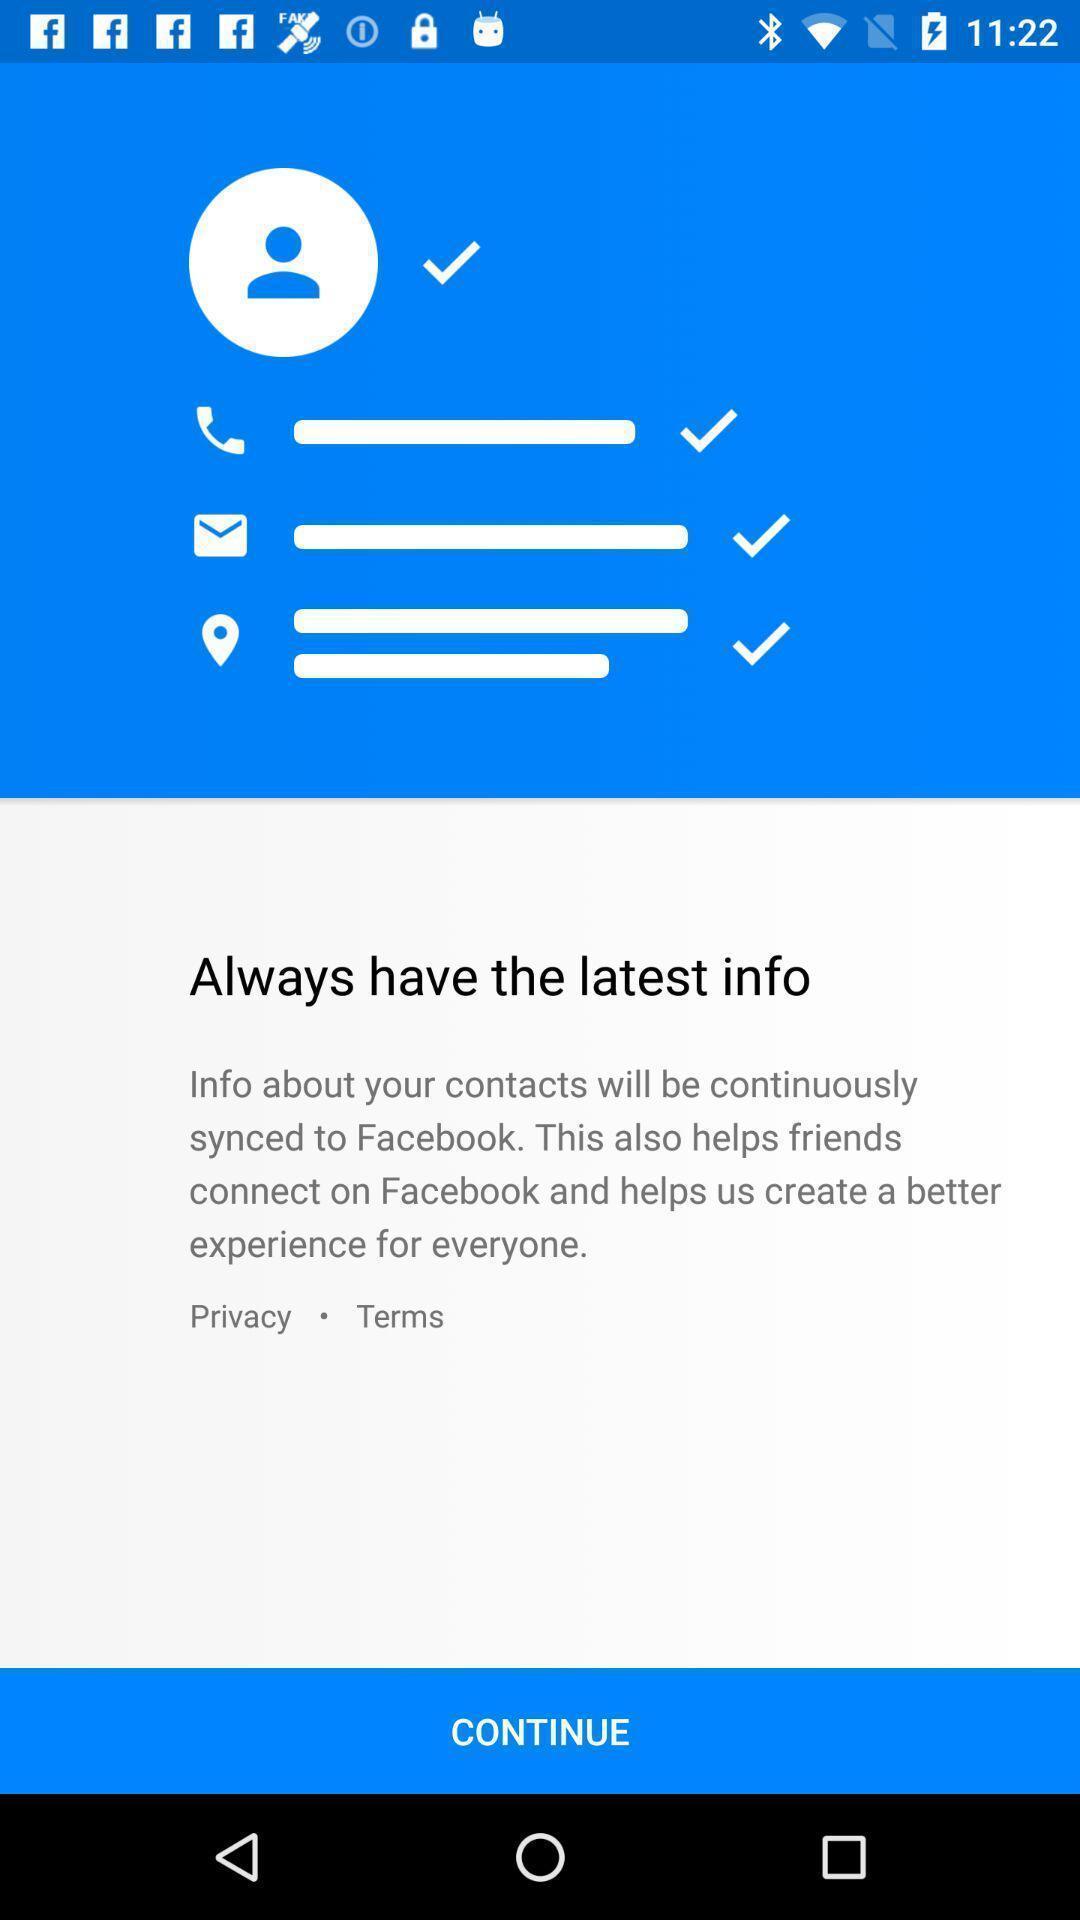Describe the key features of this screenshot. Page for social application with continue option. 